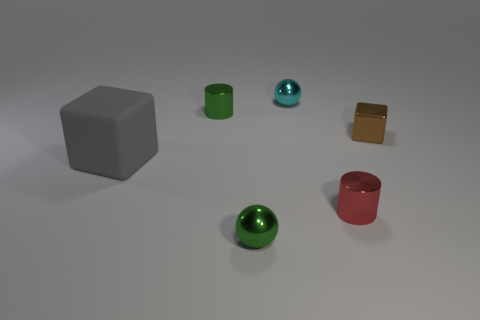Add 3 matte blocks. How many objects exist? 9 Subtract all gray cylinders. Subtract all green blocks. How many cylinders are left? 2 Subtract 0 cyan cylinders. How many objects are left? 6 Subtract all tiny blue things. Subtract all tiny green shiny cylinders. How many objects are left? 5 Add 6 small brown metallic blocks. How many small brown metallic blocks are left? 7 Add 2 cyan things. How many cyan things exist? 3 